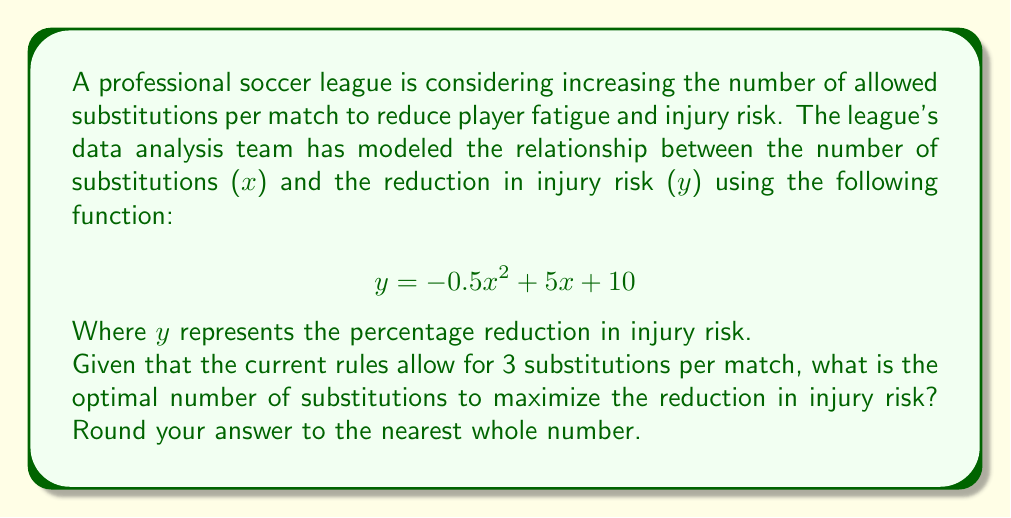Teach me how to tackle this problem. To find the optimal number of substitutions, we need to determine the maximum point of the given quadratic function. This can be done by following these steps:

1. The general form of a quadratic function is $f(x) = ax^2 + bx + c$. In this case:
   $a = -0.5$, $b = 5$, and $c = 10$

2. For a quadratic function, the x-coordinate of the vertex (which represents the maximum or minimum point) is given by the formula:

   $$x = -\frac{b}{2a}$$

3. Substituting our values:

   $$x = -\frac{5}{2(-0.5)} = -\frac{5}{-1} = 5$$

4. To verify this is a maximum (not a minimum), we can check that $a < 0$, which is true in this case.

5. Since we're asked to round to the nearest whole number, and 5 is already a whole number, our answer is 5.

6. We can double-check by calculating y for x = 4, 5, and 6:

   For x = 4: $y = -0.5(4)^2 + 5(4) + 10 = -8 + 20 + 10 = 22$
   For x = 5: $y = -0.5(5)^2 + 5(5) + 10 = -12.5 + 25 + 10 = 22.5$
   For x = 6: $y = -0.5(6)^2 + 5(6) + 10 = -18 + 30 + 10 = 22$

   This confirms that 5 substitutions yield the maximum reduction in injury risk.
Answer: 5 substitutions 